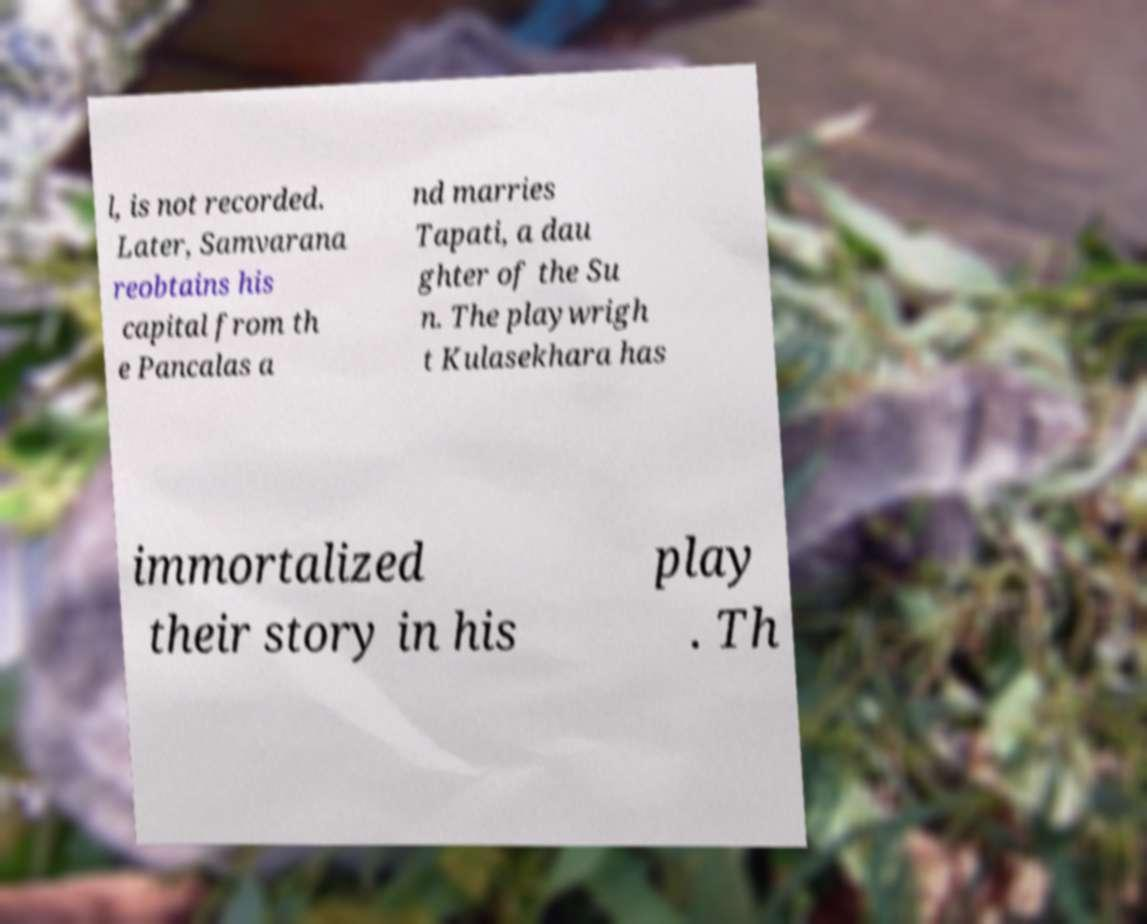Could you extract and type out the text from this image? l, is not recorded. Later, Samvarana reobtains his capital from th e Pancalas a nd marries Tapati, a dau ghter of the Su n. The playwrigh t Kulasekhara has immortalized their story in his play . Th 